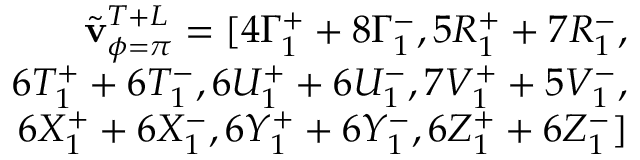<formula> <loc_0><loc_0><loc_500><loc_500>\begin{array} { r } { \tilde { v } _ { \phi = \pi } ^ { T + L } = [ 4 \Gamma _ { 1 } ^ { + } + 8 \Gamma _ { 1 } ^ { - } , 5 R _ { 1 } ^ { + } + 7 R _ { 1 } ^ { - } , } \\ { 6 T _ { 1 } ^ { + } + 6 T _ { 1 } ^ { - } , 6 U _ { 1 } ^ { + } + 6 U _ { 1 } ^ { - } , 7 V _ { 1 } ^ { + } + 5 V _ { 1 } ^ { - } , } \\ { 6 X _ { 1 } ^ { + } + 6 X _ { 1 } ^ { - } , 6 Y _ { 1 } ^ { + } + 6 Y _ { 1 } ^ { - } , 6 Z _ { 1 } ^ { + } + 6 Z _ { 1 } ^ { - } ] } \end{array}</formula> 